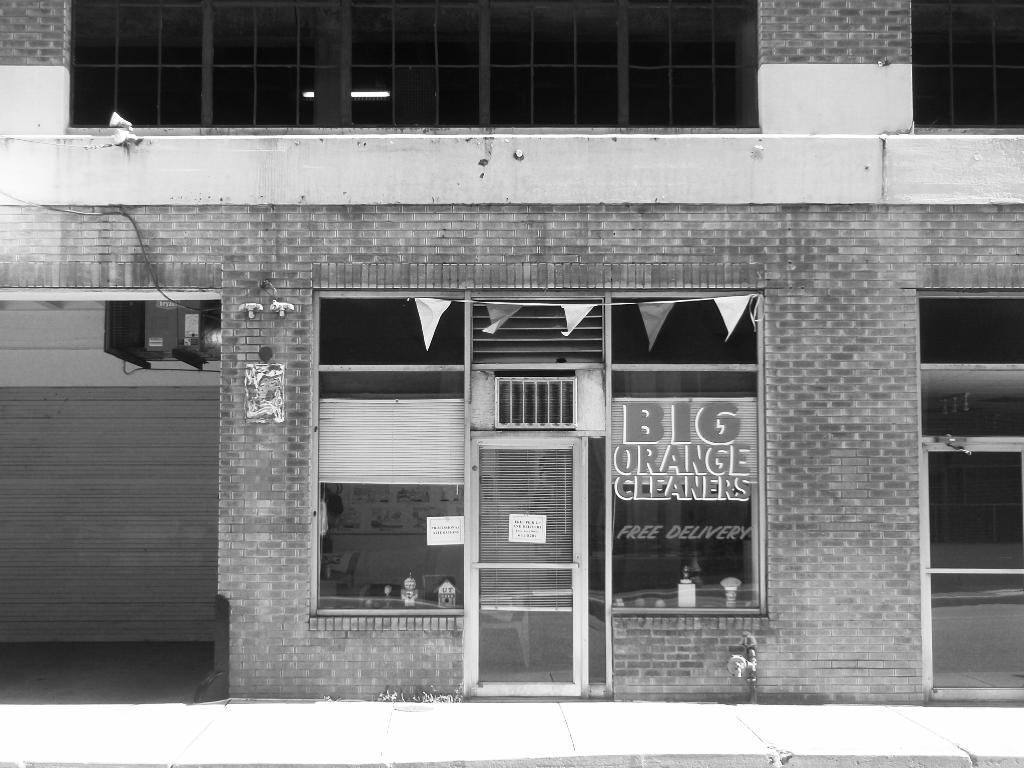How would you summarize this image in a sentence or two? In this image we can see building with windows and we can also see a poster with some text. 